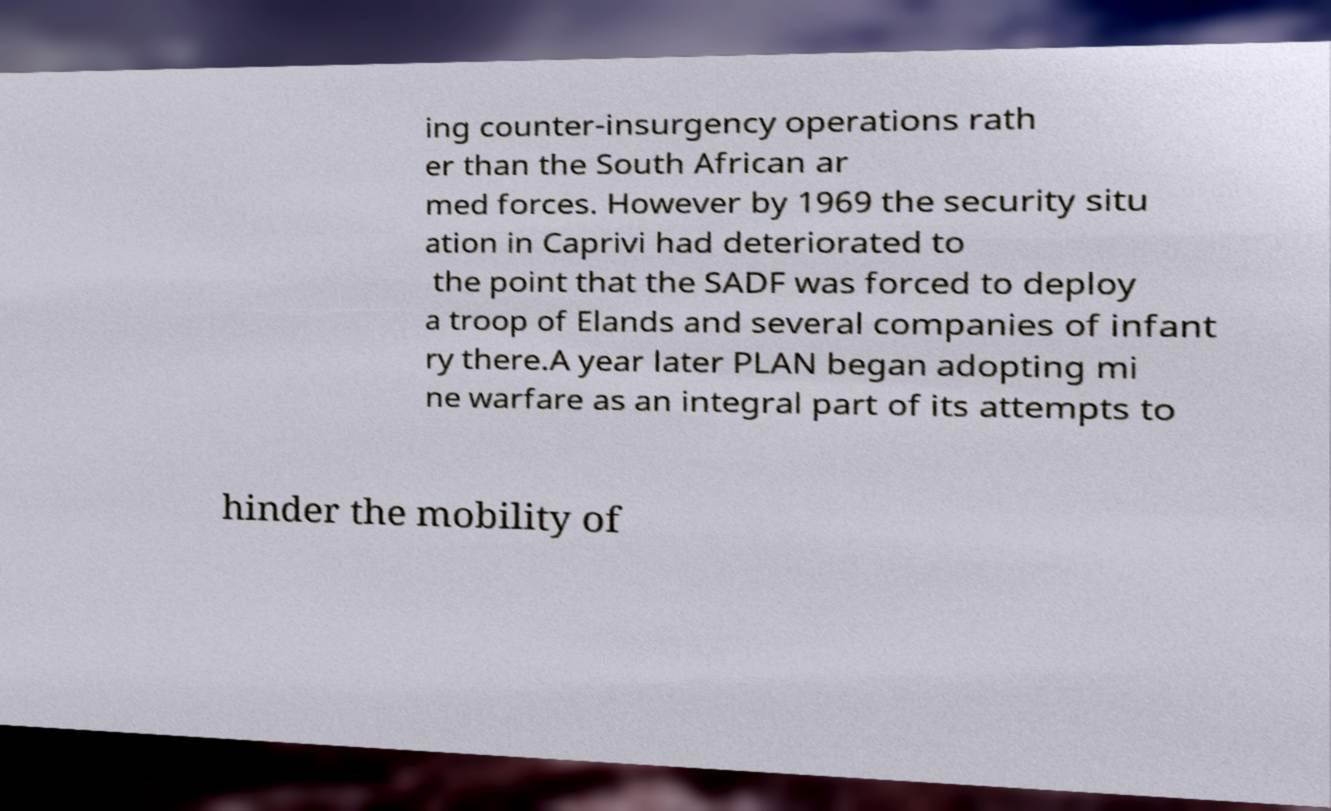There's text embedded in this image that I need extracted. Can you transcribe it verbatim? ing counter-insurgency operations rath er than the South African ar med forces. However by 1969 the security situ ation in Caprivi had deteriorated to the point that the SADF was forced to deploy a troop of Elands and several companies of infant ry there.A year later PLAN began adopting mi ne warfare as an integral part of its attempts to hinder the mobility of 